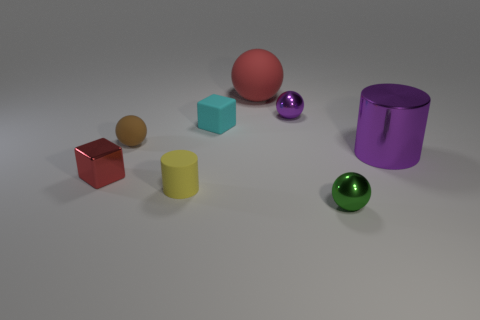Is the number of brown spheres less than the number of small rubber objects? After careful observation, it appears that the number of brown spheres, which is one, is indeed less than the number of small rubber objects in the image. 